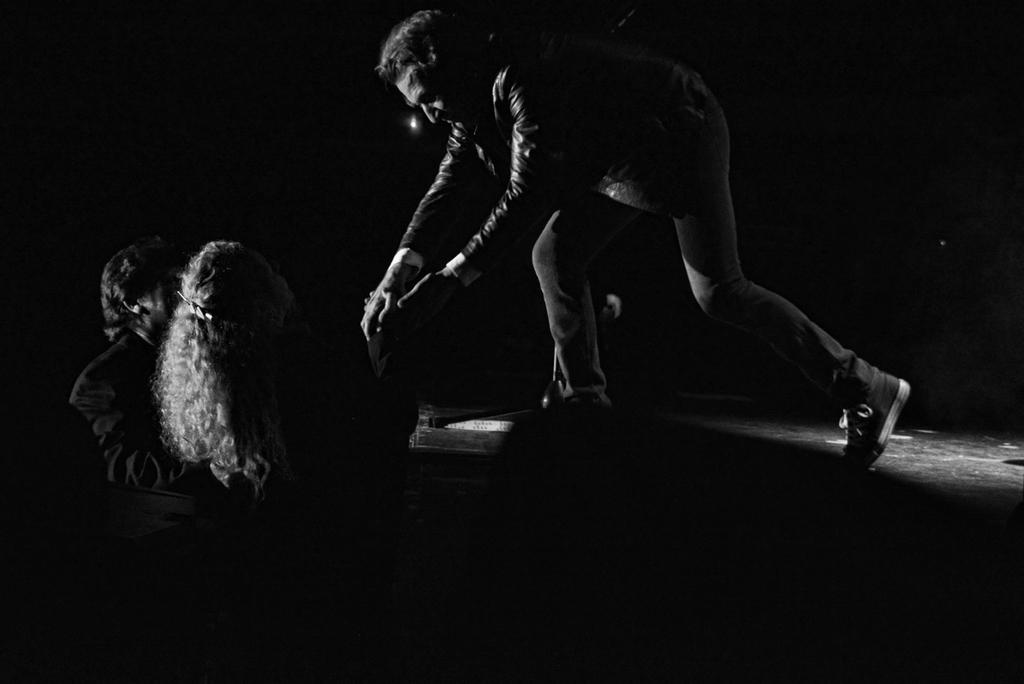What is the main subject in the center of the image? There is a person standing on a dais in the center of the image. Who else is on the dais in the image? There is a man and a woman standing on the dais on the left side of the image. What can be seen in the background of the image? There is a light in the background of the image. Where can you buy fuel for your car in the image? There is no mention of a store or fuel in the image, so it cannot be determined where you can buy fuel for your car. 